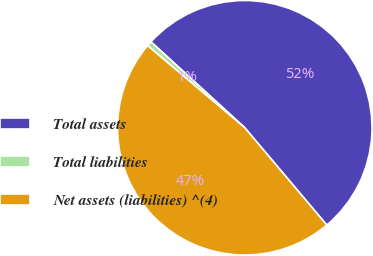Convert chart to OTSL. <chart><loc_0><loc_0><loc_500><loc_500><pie_chart><fcel>Total assets<fcel>Total liabilities<fcel>Net assets (liabilities) ^(4)<nl><fcel>52.05%<fcel>0.63%<fcel>47.32%<nl></chart> 